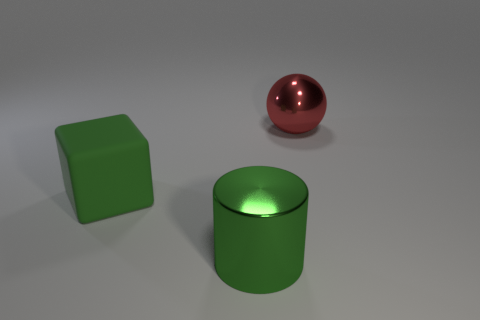Subtract all balls. How many objects are left? 2 Add 1 cyan cylinders. How many objects exist? 4 Subtract all large green objects. Subtract all matte blocks. How many objects are left? 0 Add 3 red spheres. How many red spheres are left? 4 Add 1 large yellow rubber cylinders. How many large yellow rubber cylinders exist? 1 Subtract 0 blue spheres. How many objects are left? 3 